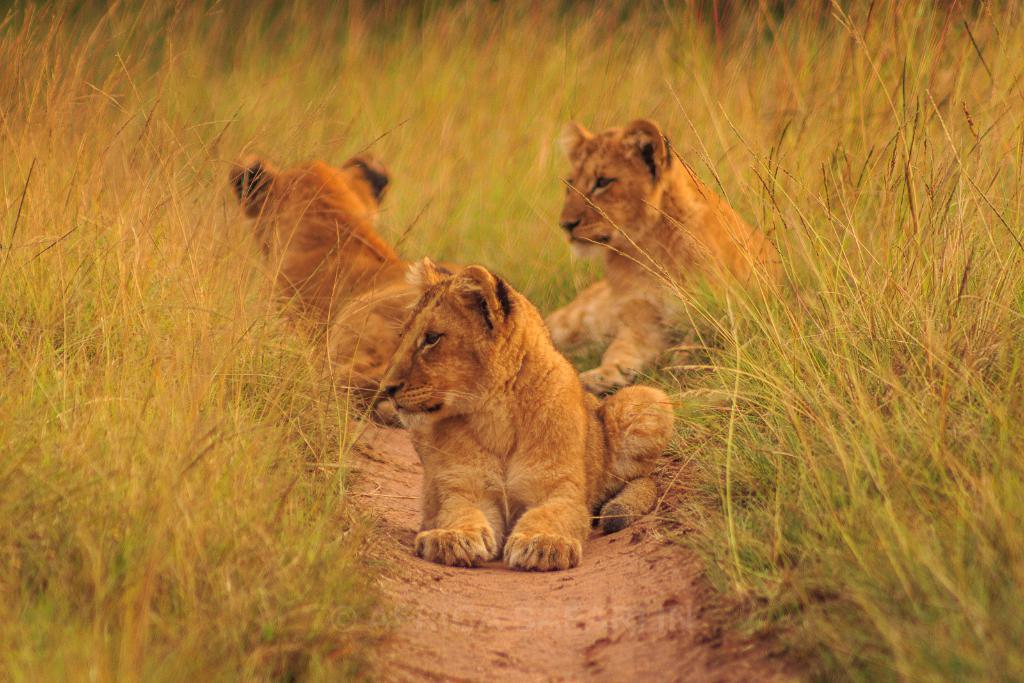Describe this image in one or two sentences. In this picture I can see there are three cubs sitting on the soil and there is grass around them. 